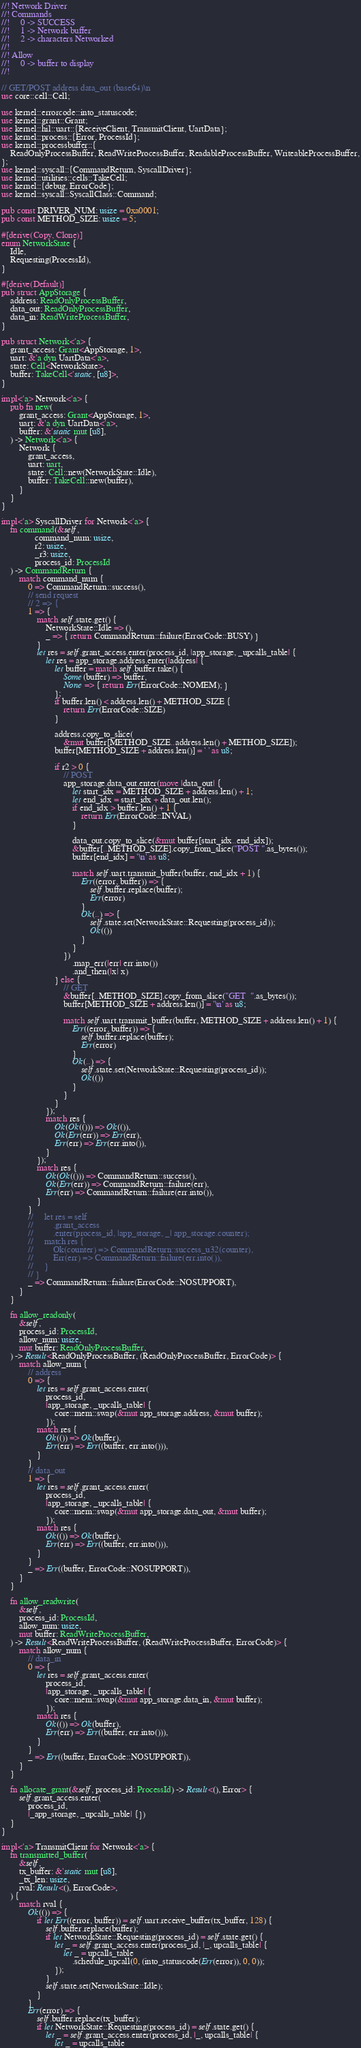Convert code to text. <code><loc_0><loc_0><loc_500><loc_500><_Rust_>//! Network Driver
//! Commands
//!     0 -> SUCCESS
//!     1 -> Network buffer
//!     2 -> characters Networked
//!
//! Allow
//!     0 -> buffer to display
//!

// GET/POST address data_out (base64)\n
use core::cell::Cell;

use kernel::errorcode::into_statuscode;
use kernel::grant::Grant;
use kernel::hil::uart::{ReceiveClient, TransmitClient, UartData};
use kernel::process::{Error, ProcessId};
use kernel::processbuffer::{
    ReadOnlyProcessBuffer, ReadWriteProcessBuffer, ReadableProcessBuffer, WriteableProcessBuffer,
};
use kernel::syscall::{CommandReturn, SyscallDriver};
use kernel::utilities::cells::TakeCell;
use kernel::{debug, ErrorCode};
use kernel::syscall::SyscallClass::Command;

pub const DRIVER_NUM: usize = 0xa0001;
pub const METHOD_SIZE: usize = 5;

#[derive(Copy, Clone)]
enum NetworkState {
    Idle,
    Requesting(ProcessId),
}

#[derive(Default)]
pub struct AppStorage {
    address: ReadOnlyProcessBuffer,
    data_out: ReadOnlyProcessBuffer,
    data_in: ReadWriteProcessBuffer,
}

pub struct Network<'a> {
    grant_access: Grant<AppStorage, 1>,
    uart: &'a dyn UartData<'a>,
    state: Cell<NetworkState>,
    buffer: TakeCell<'static, [u8]>,
}

impl<'a> Network<'a> {
    pub fn new(
        grant_access: Grant<AppStorage, 1>,
        uart: &'a dyn UartData<'a>,
        buffer: &'static mut [u8],
    ) -> Network<'a> {
        Network {
            grant_access,
            uart: uart,
            state: Cell::new(NetworkState::Idle),
            buffer: TakeCell::new(buffer),
        }
    }
}

impl<'a> SyscallDriver for Network<'a> {
    fn command(&self,
               command_num: usize,
               r2: usize,
               _r3: usize,
               process_id: ProcessId
    ) -> CommandReturn {
        match command_num {
            0 => CommandReturn::success(),
            // send request
            // 2 => {
            1 => {
                match self.state.get() {
                    NetworkState::Idle => (),
                    _ => { return CommandReturn::failure(ErrorCode::BUSY) }
                }
                let res = self.grant_access.enter(process_id, |app_storage, _upcalls_table| {
                    let res = app_storage.address.enter(|address| {
                        let buffer = match self.buffer.take() {
                            Some(buffer) => buffer,
                            None => { return Err(ErrorCode::NOMEM); }
                        };
                        if buffer.len() < address.len() + METHOD_SIZE {
                            return Err(ErrorCode::SIZE)
                        }

                        address.copy_to_slice(
                            &mut buffer[METHOD_SIZE..address.len() + METHOD_SIZE]);
                        buffer[METHOD_SIZE + address.len()] = ' ' as u8;
                        
                        if r2 > 0 {
                            // POST
                            app_storage.data_out.enter(move |data_out| {
                                let start_idx = METHOD_SIZE + address.len() + 1;
                                let end_idx = start_idx + data_out.len();
                                if end_idx > buffer.len() + 1 {
                                    return Err(ErrorCode::INVAL)
                                }

                                data_out.copy_to_slice(&mut buffer[start_idx..end_idx]);
                                &buffer[..METHOD_SIZE].copy_from_slice("POST ".as_bytes());
                                buffer[end_idx] = '\n' as u8;

                                match self.uart.transmit_buffer(buffer, end_idx + 1) {
                                    Err((error, buffer)) => {
                                        self.buffer.replace(buffer);
                                        Err(error)
                                    }
                                    Ok(..) => {
                                        self.state.set(NetworkState::Requesting(process_id));
                                        Ok(())
                                    }
                                }
                            })
                                .map_err(|err| err.into())
                                .and_then(|x| x)
                        } else {
                            // GET
                            &buffer[..METHOD_SIZE].copy_from_slice("GET  ".as_bytes());
                            buffer[METHOD_SIZE + address.len()] = '\n' as u8;

                            match self.uart.transmit_buffer(buffer, METHOD_SIZE + address.len() + 1) {
                                Err((error, buffer)) => {
                                    self.buffer.replace(buffer);
                                    Err(error)
                                }
                                Ok(..) => {
                                    self.state.set(NetworkState::Requesting(process_id));
                                    Ok(())
                                }
                            }
                        }
                    });
                    match res {
                        Ok(Ok(())) => Ok(()),
                        Ok(Err(err)) => Err(err),
                        Err(err) => Err(err.into()),
                    }
                });
                match res {
                    Ok(Ok(())) => CommandReturn::success(),
                    Ok(Err(err)) => CommandReturn::failure(err),
                    Err(err) => CommandReturn::failure(err.into()),
                }
            }
            //     let res = self
            //         .grant_access
            //         .enter(process_id, |app_storage, _| app_storage.counter);
            //     match res {
            //         Ok(counter) => CommandReturn::success_u32(counter),
            //         Err(err) => CommandReturn::failure(err.into()),
            //     }
            // }
            _ => CommandReturn::failure(ErrorCode::NOSUPPORT),
        }
    }

    fn allow_readonly(
        &self,
        process_id: ProcessId,
        allow_num: usize,
        mut buffer: ReadOnlyProcessBuffer,
    ) -> Result<ReadOnlyProcessBuffer, (ReadOnlyProcessBuffer, ErrorCode)> {
        match allow_num {
            // address
            0 => {
                let res = self.grant_access.enter(
                    process_id,
                    |app_storage, _upcalls_table| {
                        core::mem::swap(&mut app_storage.address, &mut buffer);
                    });
                match res {
                    Ok(()) => Ok(buffer),
                    Err(err) => Err((buffer, err.into())),
                }
            }
            // data_out
            1 => {
                let res = self.grant_access.enter(
                    process_id,
                    |app_storage, _upcalls_table| {
                        core::mem::swap(&mut app_storage.data_out, &mut buffer);
                    });
                match res {
                    Ok(()) => Ok(buffer),
                    Err(err) => Err((buffer, err.into())),
                }
            }
            _ => Err((buffer, ErrorCode::NOSUPPORT)),
        }
    }

    fn allow_readwrite(
        &self,
        process_id: ProcessId,
        allow_num: usize,
        mut buffer: ReadWriteProcessBuffer,
    ) -> Result<ReadWriteProcessBuffer, (ReadWriteProcessBuffer, ErrorCode)> {
        match allow_num {
            // data_in
            0 => {
                let res = self.grant_access.enter(
                    process_id,
                    |app_storage, _upcalls_table| {
                        core::mem::swap(&mut app_storage.data_in, &mut buffer);
                    });
                match res {
                    Ok(()) => Ok(buffer),
                    Err(err) => Err((buffer, err.into())),
                }
            }
            _ => Err((buffer, ErrorCode::NOSUPPORT)),
        }
    }

    fn allocate_grant(&self, process_id: ProcessId) -> Result<(), Error> {
        self.grant_access.enter(
            process_id,
            |_app_storage, _upcalls_table| {})
    }
}

impl<'a> TransmitClient for Network<'a> {
    fn transmitted_buffer(
        &self,
        tx_buffer: &'static mut [u8],
        _tx_len: usize,
        rval: Result<(), ErrorCode>,
    ) {
        match rval {
            Ok(()) => {
                if let Err((error, buffer)) = self.uart.receive_buffer(tx_buffer, 128) {
                    self.buffer.replace(buffer);
                    if let NetworkState::Requesting(process_id) = self.state.get() {
                        let _ = self.grant_access.enter(process_id, |_, upcalls_table| {
                            let _ = upcalls_table
                                .schedule_upcall(0, (into_statuscode(Err(error)), 0, 0));
                        });
                    }
                    self.state.set(NetworkState::Idle);
                }
            }
            Err(error) => {
                self.buffer.replace(tx_buffer);
                if let NetworkState::Requesting(process_id) = self.state.get() {
                    let _ = self.grant_access.enter(process_id, |_, upcalls_table| {
                        let _ = upcalls_table</code> 